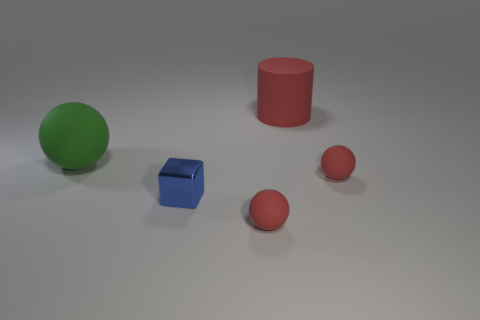Subtract all red rubber balls. How many balls are left? 1 Add 3 rubber cylinders. How many objects exist? 8 Subtract all green spheres. How many spheres are left? 2 Subtract all blocks. How many objects are left? 4 Subtract all green spheres. Subtract all tiny gray matte cylinders. How many objects are left? 4 Add 5 green rubber things. How many green rubber things are left? 6 Add 5 brown shiny blocks. How many brown shiny blocks exist? 5 Subtract 0 purple cylinders. How many objects are left? 5 Subtract 1 cubes. How many cubes are left? 0 Subtract all gray spheres. Subtract all yellow cubes. How many spheres are left? 3 